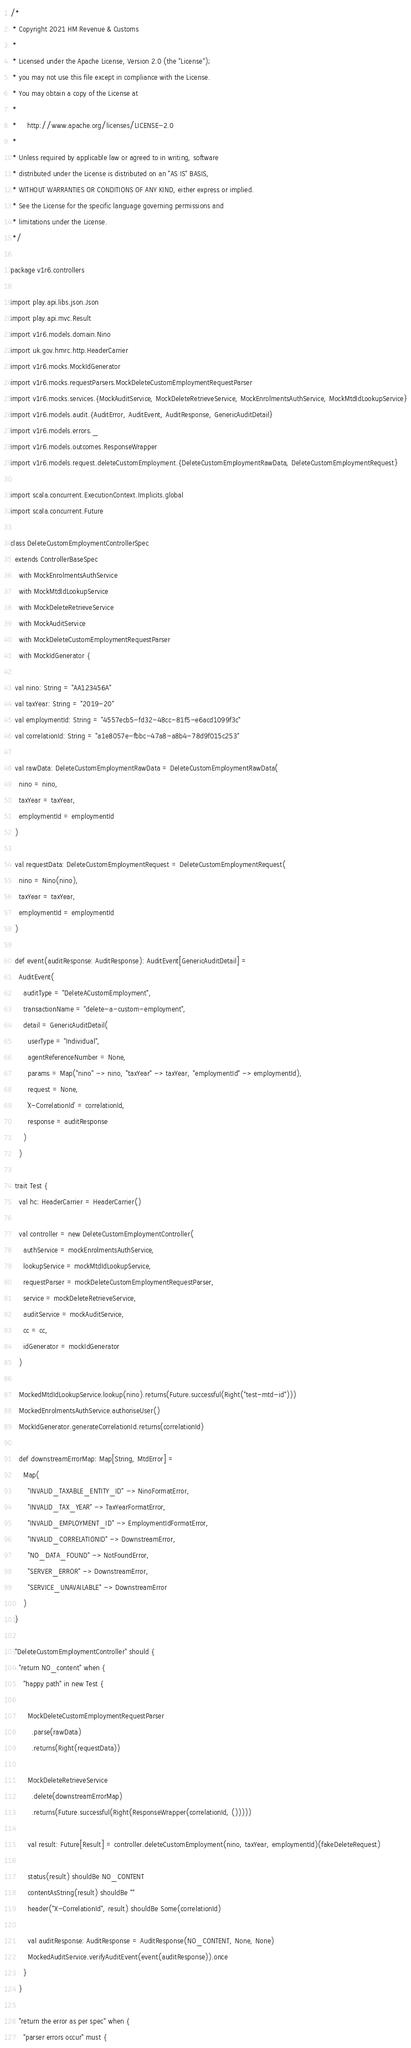Convert code to text. <code><loc_0><loc_0><loc_500><loc_500><_Scala_>/*
 * Copyright 2021 HM Revenue & Customs
 *
 * Licensed under the Apache License, Version 2.0 (the "License");
 * you may not use this file except in compliance with the License.
 * You may obtain a copy of the License at
 *
 *     http://www.apache.org/licenses/LICENSE-2.0
 *
 * Unless required by applicable law or agreed to in writing, software
 * distributed under the License is distributed on an "AS IS" BASIS,
 * WITHOUT WARRANTIES OR CONDITIONS OF ANY KIND, either express or implied.
 * See the License for the specific language governing permissions and
 * limitations under the License.
 */

package v1r6.controllers

import play.api.libs.json.Json
import play.api.mvc.Result
import v1r6.models.domain.Nino
import uk.gov.hmrc.http.HeaderCarrier
import v1r6.mocks.MockIdGenerator
import v1r6.mocks.requestParsers.MockDeleteCustomEmploymentRequestParser
import v1r6.mocks.services.{MockAuditService, MockDeleteRetrieveService, MockEnrolmentsAuthService, MockMtdIdLookupService}
import v1r6.models.audit.{AuditError, AuditEvent, AuditResponse, GenericAuditDetail}
import v1r6.models.errors._
import v1r6.models.outcomes.ResponseWrapper
import v1r6.models.request.deleteCustomEmployment.{DeleteCustomEmploymentRawData, DeleteCustomEmploymentRequest}

import scala.concurrent.ExecutionContext.Implicits.global
import scala.concurrent.Future

class DeleteCustomEmploymentControllerSpec
  extends ControllerBaseSpec
    with MockEnrolmentsAuthService
    with MockMtdIdLookupService
    with MockDeleteRetrieveService
    with MockAuditService
    with MockDeleteCustomEmploymentRequestParser
    with MockIdGenerator {

  val nino: String = "AA123456A"
  val taxYear: String = "2019-20"
  val employmentId: String = "4557ecb5-fd32-48cc-81f5-e6acd1099f3c"
  val correlationId: String = "a1e8057e-fbbc-47a8-a8b4-78d9f015c253"

  val rawData: DeleteCustomEmploymentRawData = DeleteCustomEmploymentRawData(
    nino = nino,
    taxYear = taxYear,
    employmentId = employmentId
  )

  val requestData: DeleteCustomEmploymentRequest = DeleteCustomEmploymentRequest(
    nino = Nino(nino),
    taxYear = taxYear,
    employmentId = employmentId
  )

  def event(auditResponse: AuditResponse): AuditEvent[GenericAuditDetail] =
    AuditEvent(
      auditType = "DeleteACustomEmployment",
      transactionName = "delete-a-custom-employment",
      detail = GenericAuditDetail(
        userType = "Individual",
        agentReferenceNumber = None,
        params = Map("nino" -> nino, "taxYear" -> taxYear, "employmentId" -> employmentId),
        request = None,
        `X-CorrelationId` = correlationId,
        response = auditResponse
      )
    )

  trait Test {
    val hc: HeaderCarrier = HeaderCarrier()

    val controller = new DeleteCustomEmploymentController(
      authService = mockEnrolmentsAuthService,
      lookupService = mockMtdIdLookupService,
      requestParser = mockDeleteCustomEmploymentRequestParser,
      service = mockDeleteRetrieveService,
      auditService = mockAuditService,
      cc = cc,
      idGenerator = mockIdGenerator
    )

    MockedMtdIdLookupService.lookup(nino).returns(Future.successful(Right("test-mtd-id")))
    MockedEnrolmentsAuthService.authoriseUser()
    MockIdGenerator.generateCorrelationId.returns(correlationId)

    def downstreamErrorMap: Map[String, MtdError] =
      Map(
        "INVALID_TAXABLE_ENTITY_ID" -> NinoFormatError,
        "INVALID_TAX_YEAR" -> TaxYearFormatError,
        "INVALID_EMPLOYMENT_ID" -> EmploymentIdFormatError,
        "INVALID_CORRELATIONID" -> DownstreamError,
        "NO_DATA_FOUND" -> NotFoundError,
        "SERVER_ERROR" -> DownstreamError,
        "SERVICE_UNAVAILABLE" -> DownstreamError
      )
  }

  "DeleteCustomEmploymentController" should {
    "return NO_content" when {
      "happy path" in new Test {

        MockDeleteCustomEmploymentRequestParser
          .parse(rawData)
          .returns(Right(requestData))

        MockDeleteRetrieveService
          .delete(downstreamErrorMap)
          .returns(Future.successful(Right(ResponseWrapper(correlationId, ()))))

        val result: Future[Result] = controller.deleteCustomEmployment(nino, taxYear, employmentId)(fakeDeleteRequest)

        status(result) shouldBe NO_CONTENT
        contentAsString(result) shouldBe ""
        header("X-CorrelationId", result) shouldBe Some(correlationId)

        val auditResponse: AuditResponse = AuditResponse(NO_CONTENT, None, None)
        MockedAuditService.verifyAuditEvent(event(auditResponse)).once
      }
    }

    "return the error as per spec" when {
      "parser errors occur" must {</code> 